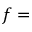<formula> <loc_0><loc_0><loc_500><loc_500>f =</formula> 